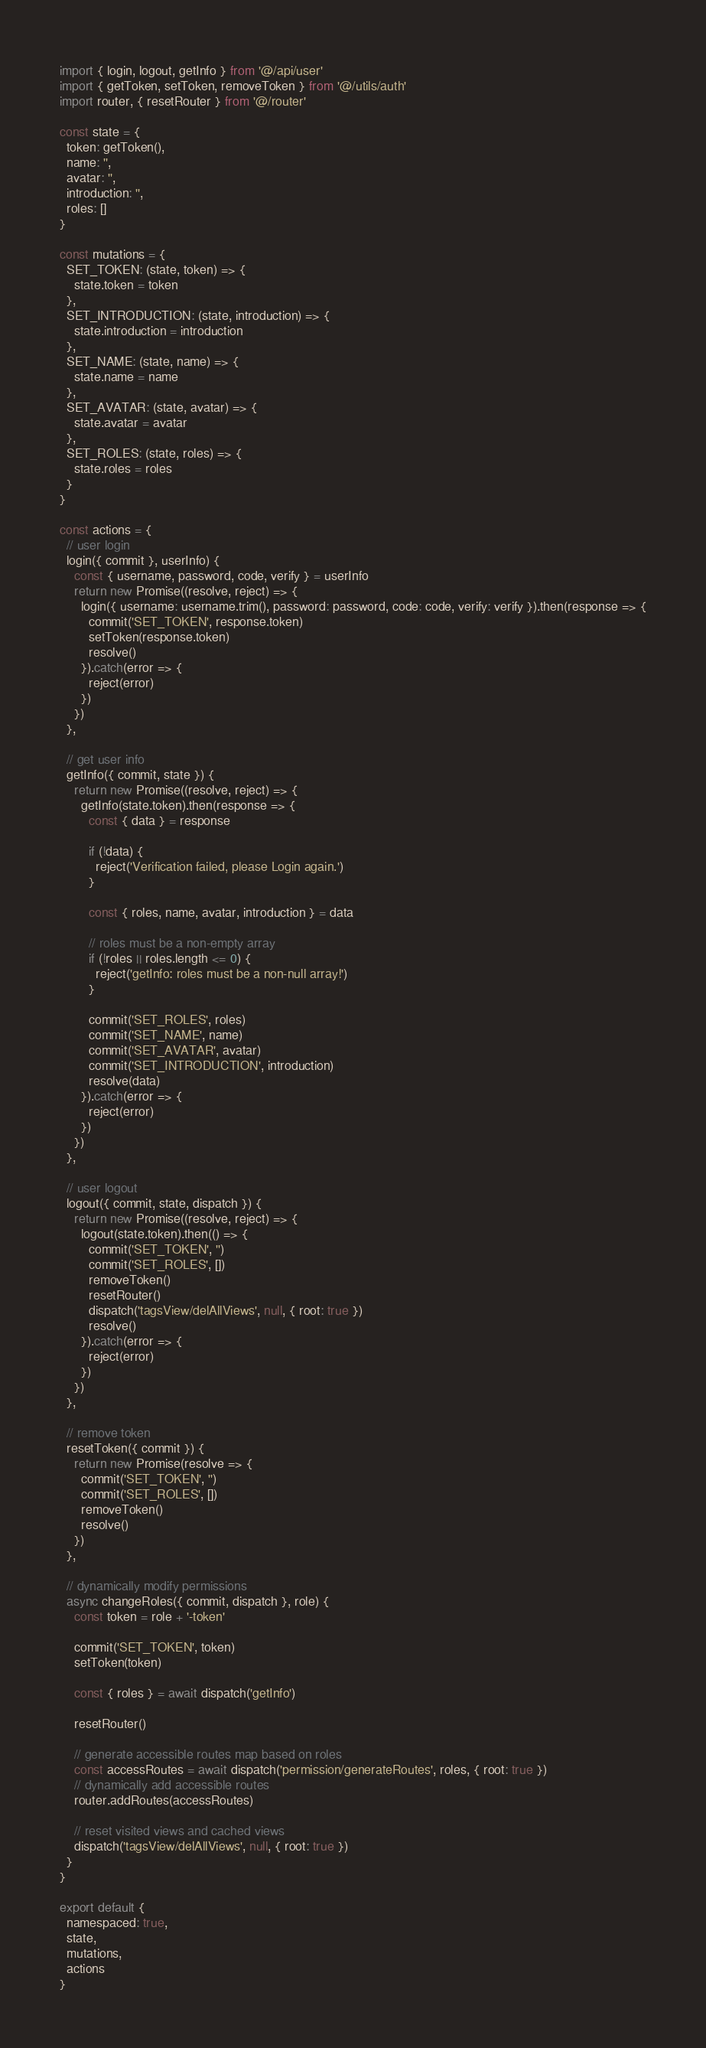<code> <loc_0><loc_0><loc_500><loc_500><_JavaScript_>import { login, logout, getInfo } from '@/api/user'
import { getToken, setToken, removeToken } from '@/utils/auth'
import router, { resetRouter } from '@/router'

const state = {
  token: getToken(),
  name: '',
  avatar: '',
  introduction: '',
  roles: []
}

const mutations = {
  SET_TOKEN: (state, token) => {
    state.token = token
  },
  SET_INTRODUCTION: (state, introduction) => {
    state.introduction = introduction
  },
  SET_NAME: (state, name) => {
    state.name = name
  },
  SET_AVATAR: (state, avatar) => {
    state.avatar = avatar
  },
  SET_ROLES: (state, roles) => {
    state.roles = roles
  }
}

const actions = {
  // user login
  login({ commit }, userInfo) {
    const { username, password, code, verify } = userInfo
    return new Promise((resolve, reject) => {
      login({ username: username.trim(), password: password, code: code, verify: verify }).then(response => {
        commit('SET_TOKEN', response.token)
        setToken(response.token)
        resolve()
      }).catch(error => {
        reject(error)
      })
    })
  },

  // get user info
  getInfo({ commit, state }) {
    return new Promise((resolve, reject) => {
      getInfo(state.token).then(response => {
        const { data } = response

        if (!data) {
          reject('Verification failed, please Login again.')
        }

        const { roles, name, avatar, introduction } = data

        // roles must be a non-empty array
        if (!roles || roles.length <= 0) {
          reject('getInfo: roles must be a non-null array!')
        }

        commit('SET_ROLES', roles)
        commit('SET_NAME', name)
        commit('SET_AVATAR', avatar)
        commit('SET_INTRODUCTION', introduction)
        resolve(data)
      }).catch(error => {
        reject(error)
      })
    })
  },

  // user logout
  logout({ commit, state, dispatch }) {
    return new Promise((resolve, reject) => {
      logout(state.token).then(() => {
        commit('SET_TOKEN', '')
        commit('SET_ROLES', [])
        removeToken()
        resetRouter()
        dispatch('tagsView/delAllViews', null, { root: true })
        resolve()
      }).catch(error => {
        reject(error)
      })
    })
  },

  // remove token
  resetToken({ commit }) {
    return new Promise(resolve => {
      commit('SET_TOKEN', '')
      commit('SET_ROLES', [])
      removeToken()
      resolve()
    })
  },

  // dynamically modify permissions
  async changeRoles({ commit, dispatch }, role) {
    const token = role + '-token'

    commit('SET_TOKEN', token)
    setToken(token)

    const { roles } = await dispatch('getInfo')

    resetRouter()

    // generate accessible routes map based on roles
    const accessRoutes = await dispatch('permission/generateRoutes', roles, { root: true })
    // dynamically add accessible routes
    router.addRoutes(accessRoutes)

    // reset visited views and cached views
    dispatch('tagsView/delAllViews', null, { root: true })
  }
}

export default {
  namespaced: true,
  state,
  mutations,
  actions
}
</code> 